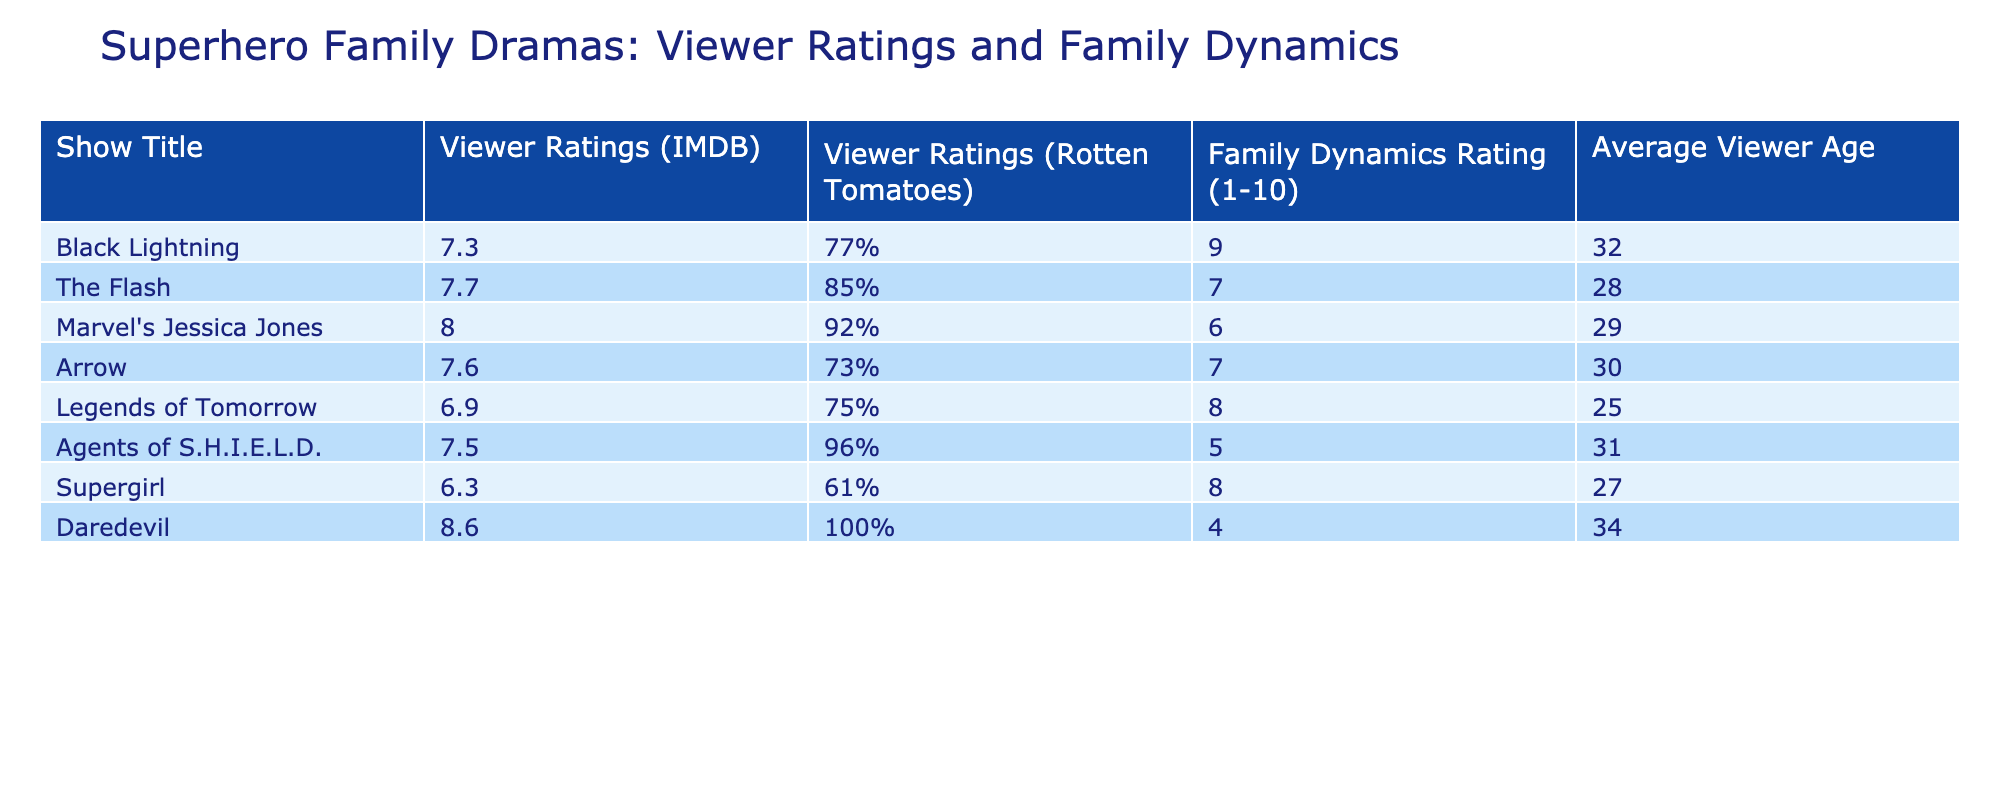What is the Viewer Rating (IMDB) for Black Lightning? According to the table, Black Lightning has an IMDB viewer rating of 7.3. This value is found directly in the “Viewer Ratings (IMDB)” column for the row labeled "Black Lightning".
Answer: 7.3 Which show has the highest Viewer Ratings (Rotten Tomatoes)? The show with the highest Ratings on Rotten Tomatoes, as indicated in the table, is Daredevil with a rating of 100%. We can see this by comparing all the values in the "Viewer Ratings (Rotten Tomatoes)" column.
Answer: Daredevil What is the average Viewer Age of all the shows listed in the table? To calculate the average Viewer Age, we sum all the ages: (32 + 28 + 29 + 30 + 25 + 31 + 27 + 34) = 236. There are 8 shows, so we divide by 8: 236 / 8 = 29.5.
Answer: 29.5 Is the Family Dynamics Rating for Supergirl higher than that of Agents of S.H.I.E.L.D.? In the table, Supergirl has a Family Dynamics Rating of 8, while Agents of S.H.I.E.L.D. has a rating of 5. Since 8 is greater than 5, the statement is true.
Answer: Yes What is the difference in Family Dynamics Ratings between The Flash and Black Lightning? The Flash has a Family Dynamics Rating of 7, while Black Lightning has a rating of 9. To find the difference, we subtract: 9 - 7 = 2.
Answer: 2 Which show, on average, has a younger audience, Legends of Tomorrow or The Flash? Legends of Tomorrow has an average viewer age of 25 and The Flash has an average viewer age of 28. Since 25 is less than 28, Legends of Tomorrow has a younger audience than The Flash.
Answer: Legends of Tomorrow Is there any show that has a Family Dynamics Rating of 10 or higher? By examining the "Family Dynamics Rating" column, we can see that no show has a rating of 10 or higher, as the maximum value listed is 9 for Black Lightning.
Answer: No Which superhero family drama has the lowest IMDB rating? Looking at the table, Legends of Tomorrow has the lowest IMDB rating at 6.9, as it is the smallest number found in the "Viewer Ratings (IMDB)" column.
Answer: Legends of Tomorrow 